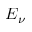<formula> <loc_0><loc_0><loc_500><loc_500>E _ { \nu }</formula> 